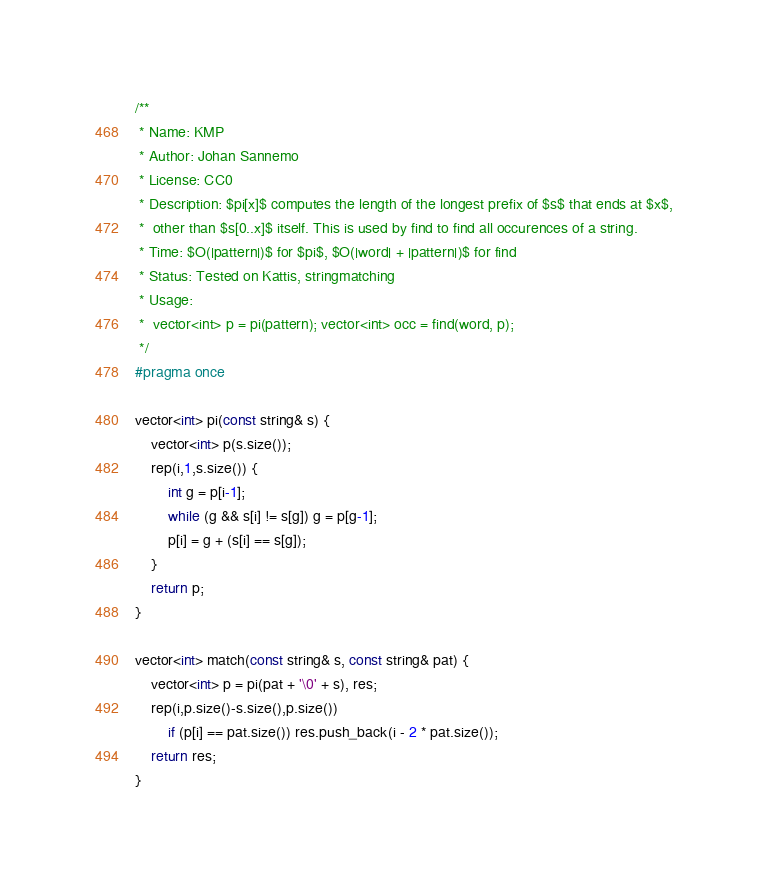Convert code to text. <code><loc_0><loc_0><loc_500><loc_500><_C_>/**
 * Name: KMP
 * Author: Johan Sannemo
 * License: CC0
 * Description: $pi[x]$ computes the length of the longest prefix of $s$ that ends at $x$,
 *  other than $s[0..x]$ itself. This is used by find to find all occurences of a string.
 * Time: $O(|pattern|)$ for $pi$, $O(|word| + |pattern|)$ for find
 * Status: Tested on Kattis, stringmatching
 * Usage:
 *  vector<int> p = pi(pattern); vector<int> occ = find(word, p);
 */
#pragma once

vector<int> pi(const string& s) {
	vector<int> p(s.size());
	rep(i,1,s.size()) {
		int g = p[i-1];
		while (g && s[i] != s[g]) g = p[g-1];
		p[i] = g + (s[i] == s[g]);
	}
	return p;
}

vector<int> match(const string& s, const string& pat) {
	vector<int> p = pi(pat + '\0' + s), res;
	rep(i,p.size()-s.size(),p.size())
		if (p[i] == pat.size()) res.push_back(i - 2 * pat.size());
	return res;
}
</code> 